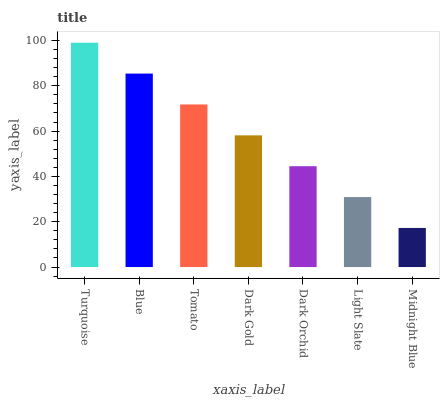Is Midnight Blue the minimum?
Answer yes or no. Yes. Is Turquoise the maximum?
Answer yes or no. Yes. Is Blue the minimum?
Answer yes or no. No. Is Blue the maximum?
Answer yes or no. No. Is Turquoise greater than Blue?
Answer yes or no. Yes. Is Blue less than Turquoise?
Answer yes or no. Yes. Is Blue greater than Turquoise?
Answer yes or no. No. Is Turquoise less than Blue?
Answer yes or no. No. Is Dark Gold the high median?
Answer yes or no. Yes. Is Dark Gold the low median?
Answer yes or no. Yes. Is Tomato the high median?
Answer yes or no. No. Is Tomato the low median?
Answer yes or no. No. 